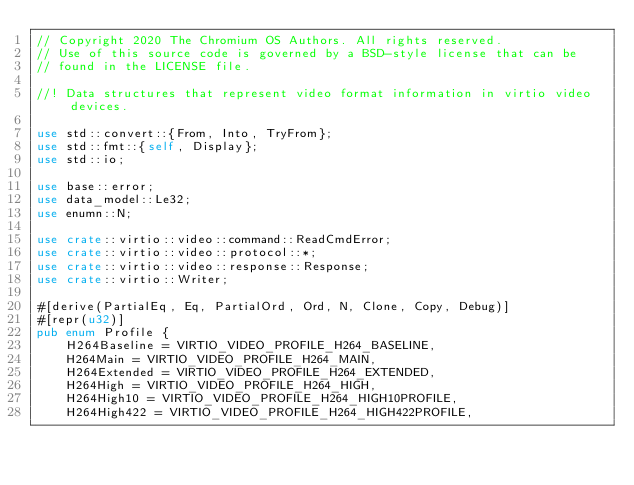<code> <loc_0><loc_0><loc_500><loc_500><_Rust_>// Copyright 2020 The Chromium OS Authors. All rights reserved.
// Use of this source code is governed by a BSD-style license that can be
// found in the LICENSE file.

//! Data structures that represent video format information in virtio video devices.

use std::convert::{From, Into, TryFrom};
use std::fmt::{self, Display};
use std::io;

use base::error;
use data_model::Le32;
use enumn::N;

use crate::virtio::video::command::ReadCmdError;
use crate::virtio::video::protocol::*;
use crate::virtio::video::response::Response;
use crate::virtio::Writer;

#[derive(PartialEq, Eq, PartialOrd, Ord, N, Clone, Copy, Debug)]
#[repr(u32)]
pub enum Profile {
    H264Baseline = VIRTIO_VIDEO_PROFILE_H264_BASELINE,
    H264Main = VIRTIO_VIDEO_PROFILE_H264_MAIN,
    H264Extended = VIRTIO_VIDEO_PROFILE_H264_EXTENDED,
    H264High = VIRTIO_VIDEO_PROFILE_H264_HIGH,
    H264High10 = VIRTIO_VIDEO_PROFILE_H264_HIGH10PROFILE,
    H264High422 = VIRTIO_VIDEO_PROFILE_H264_HIGH422PROFILE,</code> 